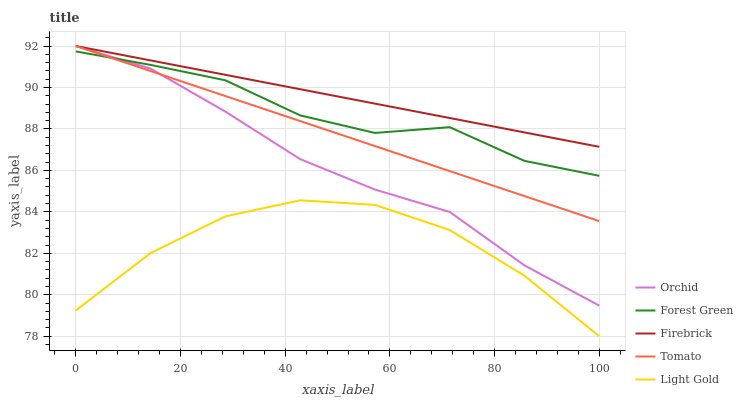Does Light Gold have the minimum area under the curve?
Answer yes or no. Yes. Does Firebrick have the maximum area under the curve?
Answer yes or no. Yes. Does Forest Green have the minimum area under the curve?
Answer yes or no. No. Does Forest Green have the maximum area under the curve?
Answer yes or no. No. Is Firebrick the smoothest?
Answer yes or no. Yes. Is Forest Green the roughest?
Answer yes or no. Yes. Is Light Gold the smoothest?
Answer yes or no. No. Is Light Gold the roughest?
Answer yes or no. No. Does Light Gold have the lowest value?
Answer yes or no. Yes. Does Forest Green have the lowest value?
Answer yes or no. No. Does Orchid have the highest value?
Answer yes or no. Yes. Does Forest Green have the highest value?
Answer yes or no. No. Is Light Gold less than Tomato?
Answer yes or no. Yes. Is Firebrick greater than Light Gold?
Answer yes or no. Yes. Does Orchid intersect Tomato?
Answer yes or no. Yes. Is Orchid less than Tomato?
Answer yes or no. No. Is Orchid greater than Tomato?
Answer yes or no. No. Does Light Gold intersect Tomato?
Answer yes or no. No. 